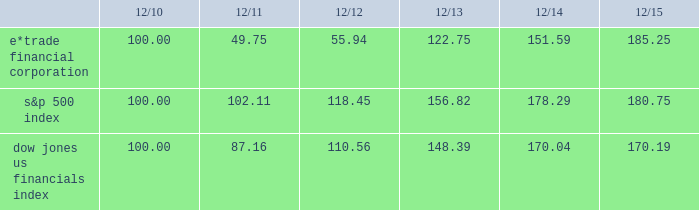Table of contents performance graph the following performance graph shows the cumulative total return to a holder of the company 2019s common stock , assuming dividend reinvestment , compared with the cumulative total return , assuming dividend reinvestment , of the standard & poor ( "s&p" ) 500 index and the dow jones us financials index during the period from december 31 , 2010 through december 31 , 2015. .

As of the 12/2014 what was the ratio of the cumulative total return to a holder of the company 2019s common stocke*trade financial corporation to s&p 500 index? 
Rationale: as of the 12/2014 there was $ 0.85 of cumulative total return to a holder of the company 2019s common stocke*trade financial corporation to s&p 500 index
Computations: (151.59 / 178.29)
Answer: 0.85024. 